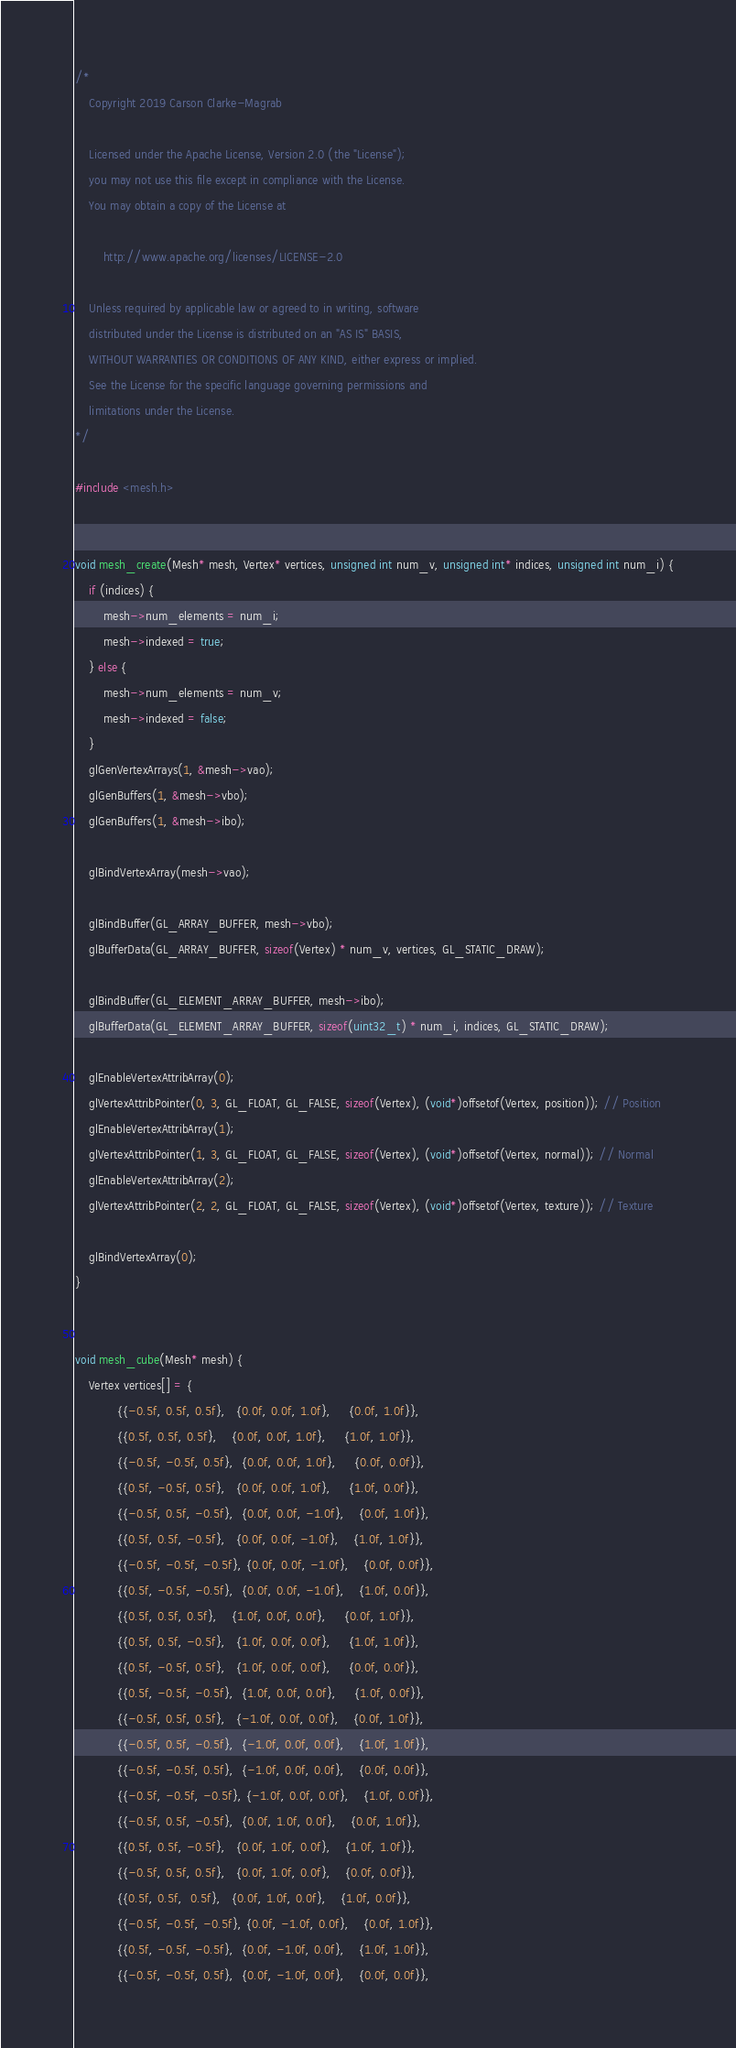<code> <loc_0><loc_0><loc_500><loc_500><_C++_>/*
    Copyright 2019 Carson Clarke-Magrab

    Licensed under the Apache License, Version 2.0 (the "License");
    you may not use this file except in compliance with the License.
    You may obtain a copy of the License at

        http://www.apache.org/licenses/LICENSE-2.0

    Unless required by applicable law or agreed to in writing, software
    distributed under the License is distributed on an "AS IS" BASIS,
    WITHOUT WARRANTIES OR CONDITIONS OF ANY KIND, either express or implied.
    See the License for the specific language governing permissions and
    limitations under the License.
*/

#include <mesh.h>


void mesh_create(Mesh* mesh, Vertex* vertices, unsigned int num_v, unsigned int* indices, unsigned int num_i) {
    if (indices) {
        mesh->num_elements = num_i;
        mesh->indexed = true;
    } else {
        mesh->num_elements = num_v;
        mesh->indexed = false;
    }
    glGenVertexArrays(1, &mesh->vao);
    glGenBuffers(1, &mesh->vbo);
    glGenBuffers(1, &mesh->ibo);

    glBindVertexArray(mesh->vao);

    glBindBuffer(GL_ARRAY_BUFFER, mesh->vbo);
    glBufferData(GL_ARRAY_BUFFER, sizeof(Vertex) * num_v, vertices, GL_STATIC_DRAW);

    glBindBuffer(GL_ELEMENT_ARRAY_BUFFER, mesh->ibo);
    glBufferData(GL_ELEMENT_ARRAY_BUFFER, sizeof(uint32_t) * num_i, indices, GL_STATIC_DRAW);

    glEnableVertexAttribArray(0);
    glVertexAttribPointer(0, 3, GL_FLOAT, GL_FALSE, sizeof(Vertex), (void*)offsetof(Vertex, position)); // Position
    glEnableVertexAttribArray(1);
    glVertexAttribPointer(1, 3, GL_FLOAT, GL_FALSE, sizeof(Vertex), (void*)offsetof(Vertex, normal)); // Normal
    glEnableVertexAttribArray(2);
    glVertexAttribPointer(2, 2, GL_FLOAT, GL_FALSE, sizeof(Vertex), (void*)offsetof(Vertex, texture)); // Texture

    glBindVertexArray(0);
}


void mesh_cube(Mesh* mesh) {
    Vertex vertices[] = {
            {{-0.5f, 0.5f, 0.5f},   {0.0f, 0.0f, 1.0f},     {0.0f, 1.0f}},
            {{0.5f, 0.5f, 0.5f},    {0.0f, 0.0f, 1.0f},     {1.0f, 1.0f}},
            {{-0.5f, -0.5f, 0.5f},  {0.0f, 0.0f, 1.0f},     {0.0f, 0.0f}},
            {{0.5f, -0.5f, 0.5f},   {0.0f, 0.0f, 1.0f},     {1.0f, 0.0f}},
            {{-0.5f, 0.5f, -0.5f},  {0.0f, 0.0f, -1.0f},    {0.0f, 1.0f}},
            {{0.5f, 0.5f, -0.5f},   {0.0f, 0.0f, -1.0f},    {1.0f, 1.0f}},
            {{-0.5f, -0.5f, -0.5f}, {0.0f, 0.0f, -1.0f},    {0.0f, 0.0f}},
            {{0.5f, -0.5f, -0.5f},  {0.0f, 0.0f, -1.0f},    {1.0f, 0.0f}},
            {{0.5f, 0.5f, 0.5f},    {1.0f, 0.0f, 0.0f},     {0.0f, 1.0f}},
            {{0.5f, 0.5f, -0.5f},   {1.0f, 0.0f, 0.0f},     {1.0f, 1.0f}},
            {{0.5f, -0.5f, 0.5f},   {1.0f, 0.0f, 0.0f},     {0.0f, 0.0f}},
            {{0.5f, -0.5f, -0.5f},  {1.0f, 0.0f, 0.0f},     {1.0f, 0.0f}},
            {{-0.5f, 0.5f, 0.5f},   {-1.0f, 0.0f, 0.0f},    {0.0f, 1.0f}},
            {{-0.5f, 0.5f, -0.5f},  {-1.0f, 0.0f, 0.0f},    {1.0f, 1.0f}},
            {{-0.5f, -0.5f, 0.5f},  {-1.0f, 0.0f, 0.0f},    {0.0f, 0.0f}},
            {{-0.5f, -0.5f, -0.5f}, {-1.0f, 0.0f, 0.0f},    {1.0f, 0.0f}},
            {{-0.5f, 0.5f, -0.5f},  {0.0f, 1.0f, 0.0f},    {0.0f, 1.0f}},
            {{0.5f, 0.5f, -0.5f},   {0.0f, 1.0f, 0.0f},    {1.0f, 1.0f}},
            {{-0.5f, 0.5f, 0.5f},   {0.0f, 1.0f, 0.0f},    {0.0f, 0.0f}},
            {{0.5f, 0.5f,  0.5f},   {0.0f, 1.0f, 0.0f},    {1.0f, 0.0f}},
            {{-0.5f, -0.5f, -0.5f}, {0.0f, -1.0f, 0.0f},    {0.0f, 1.0f}},
            {{0.5f, -0.5f, -0.5f},  {0.0f, -1.0f, 0.0f},    {1.0f, 1.0f}},
            {{-0.5f, -0.5f, 0.5f},  {0.0f, -1.0f, 0.0f},    {0.0f, 0.0f}},</code> 